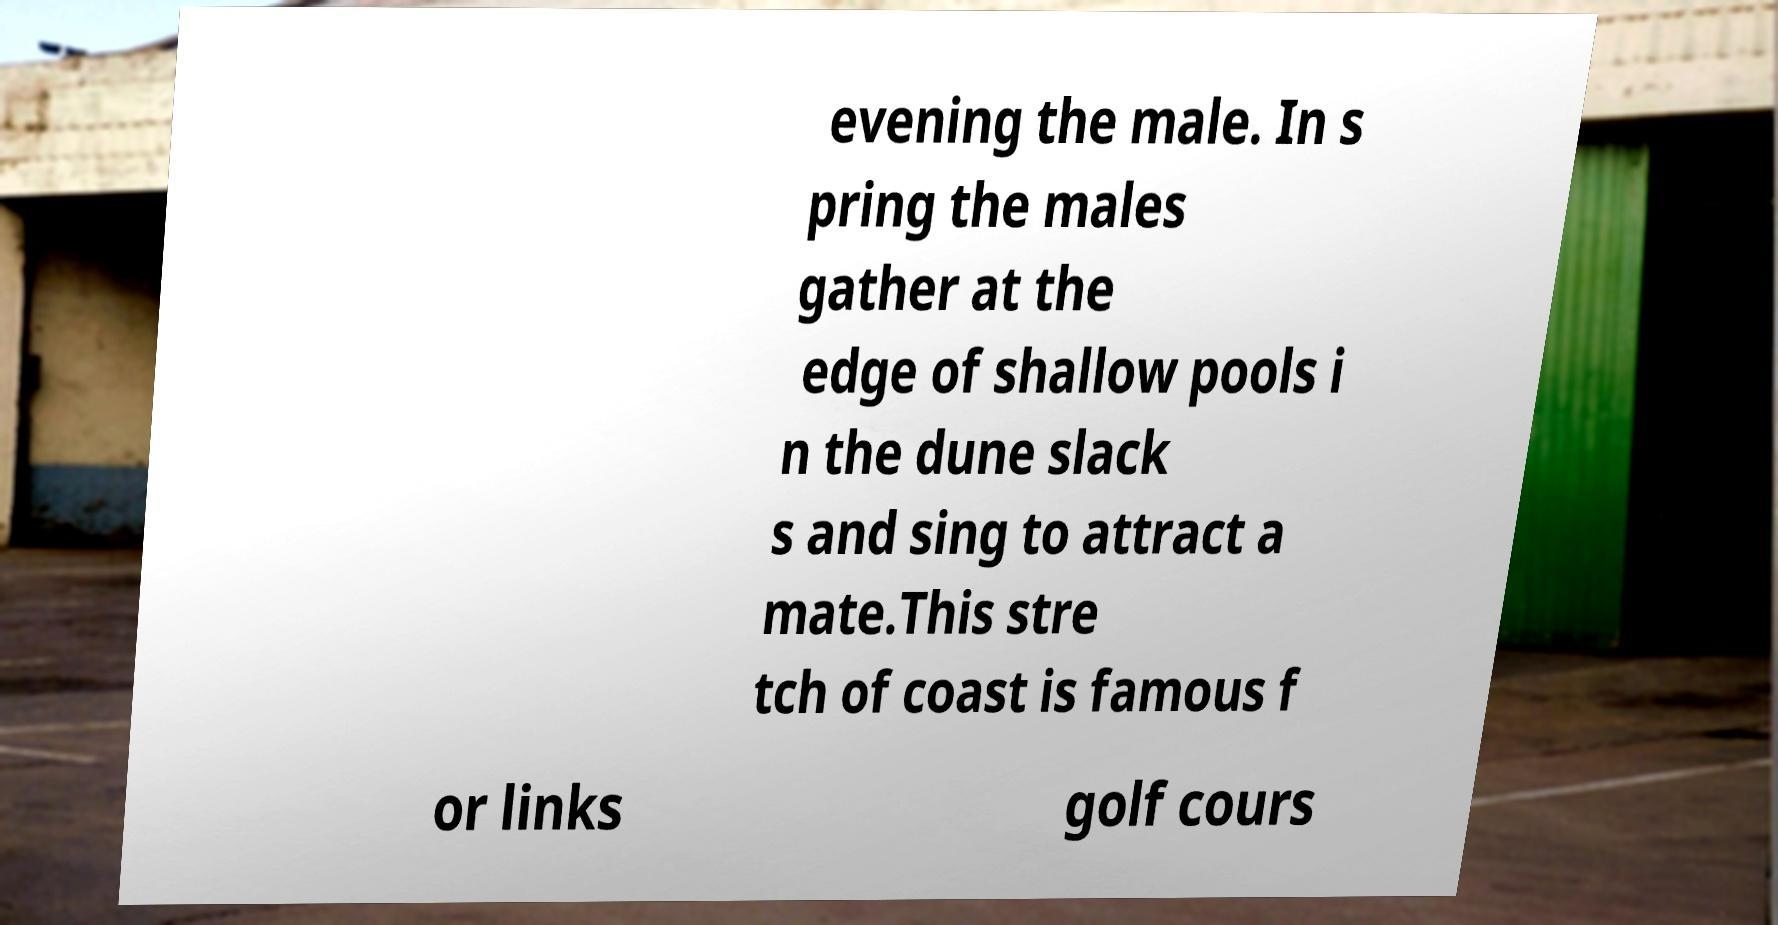Could you assist in decoding the text presented in this image and type it out clearly? evening the male. In s pring the males gather at the edge of shallow pools i n the dune slack s and sing to attract a mate.This stre tch of coast is famous f or links golf cours 